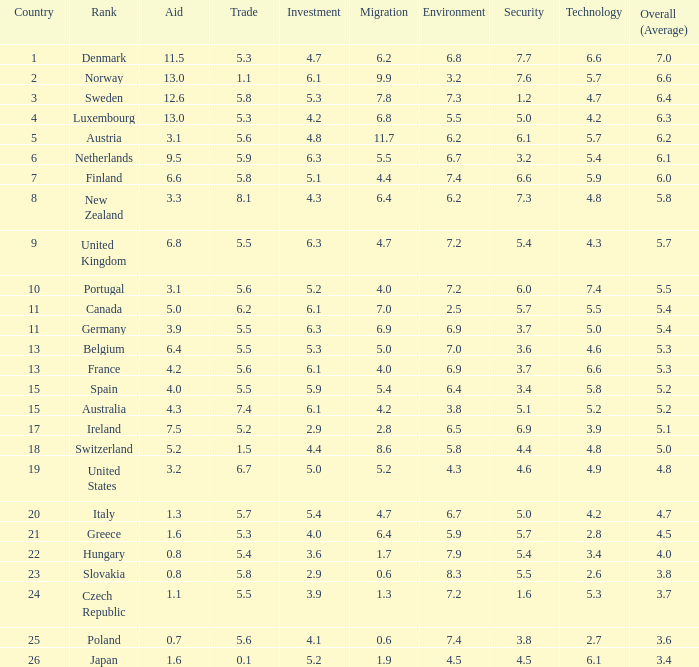What is the country with a security grade of 5.5? Slovakia. 